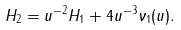<formula> <loc_0><loc_0><loc_500><loc_500>H _ { 2 } = u ^ { - 2 } H _ { 1 } + 4 u ^ { - 3 } \nu _ { 1 } ( u ) .</formula> 